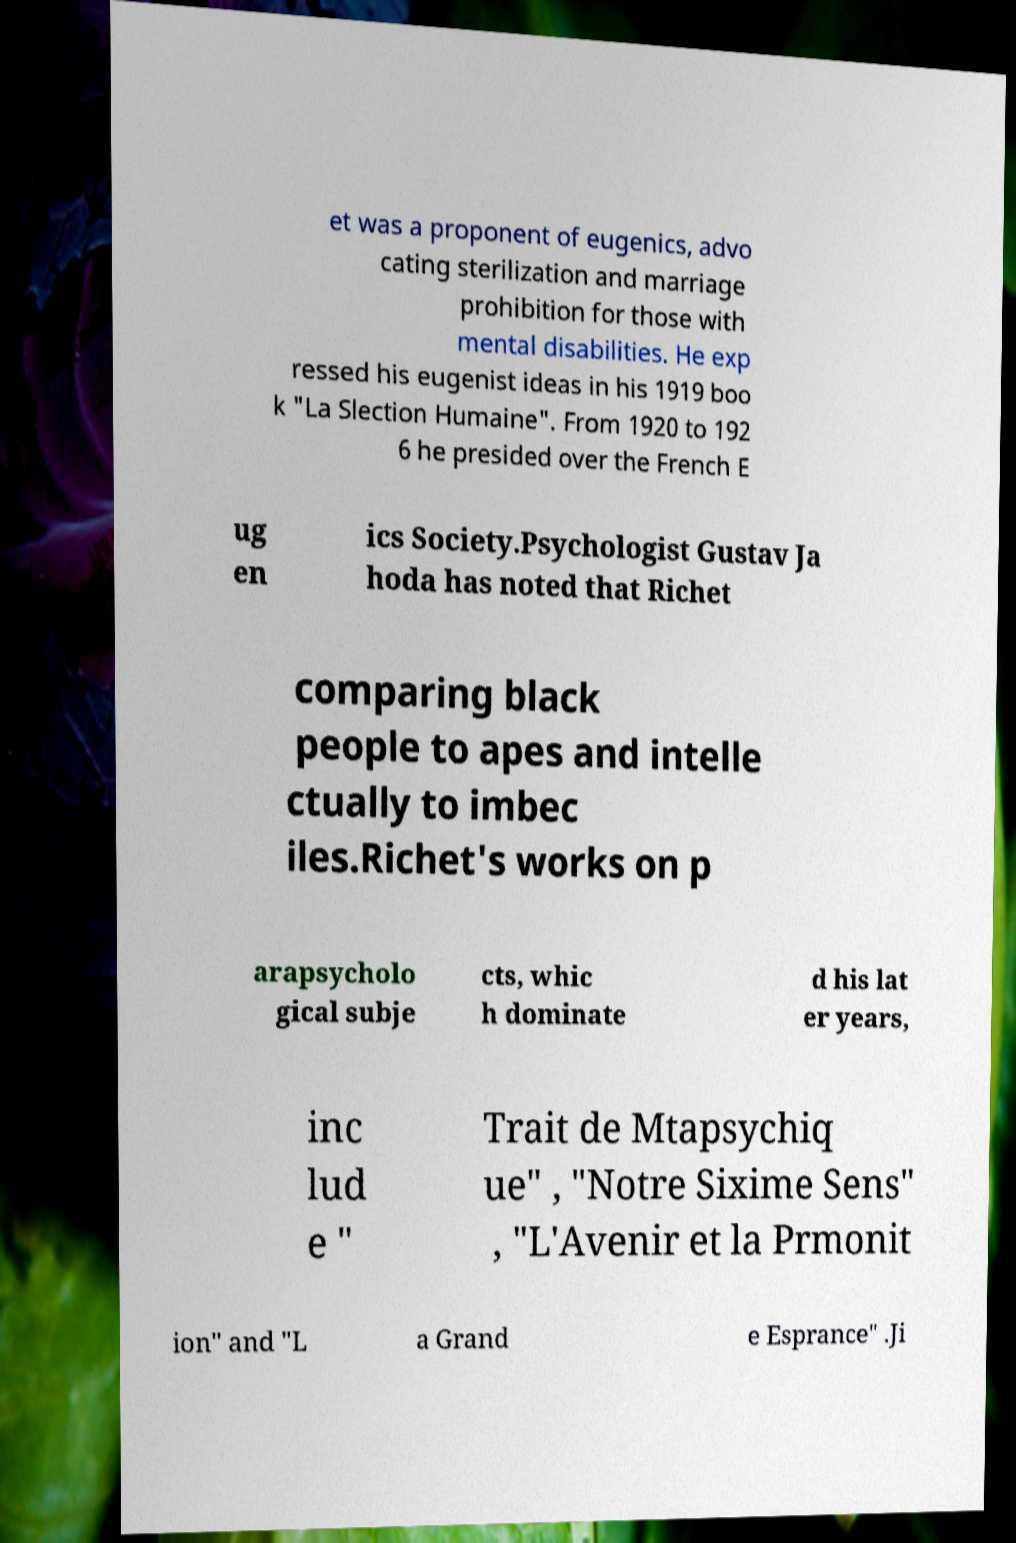What messages or text are displayed in this image? I need them in a readable, typed format. et was a proponent of eugenics, advo cating sterilization and marriage prohibition for those with mental disabilities. He exp ressed his eugenist ideas in his 1919 boo k "La Slection Humaine". From 1920 to 192 6 he presided over the French E ug en ics Society.Psychologist Gustav Ja hoda has noted that Richet comparing black people to apes and intelle ctually to imbec iles.Richet's works on p arapsycholo gical subje cts, whic h dominate d his lat er years, inc lud e " Trait de Mtapsychiq ue" , "Notre Sixime Sens" , "L'Avenir et la Prmonit ion" and "L a Grand e Esprance" .Ji 